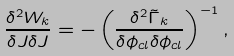Convert formula to latex. <formula><loc_0><loc_0><loc_500><loc_500>\frac { \delta ^ { 2 } W _ { k } } { \delta J \delta J } = - \left ( \frac { \delta ^ { 2 } \tilde { \Gamma } _ { k } } { \delta \phi _ { c l } \delta \phi _ { c l } } \right ) ^ { - 1 } ,</formula> 